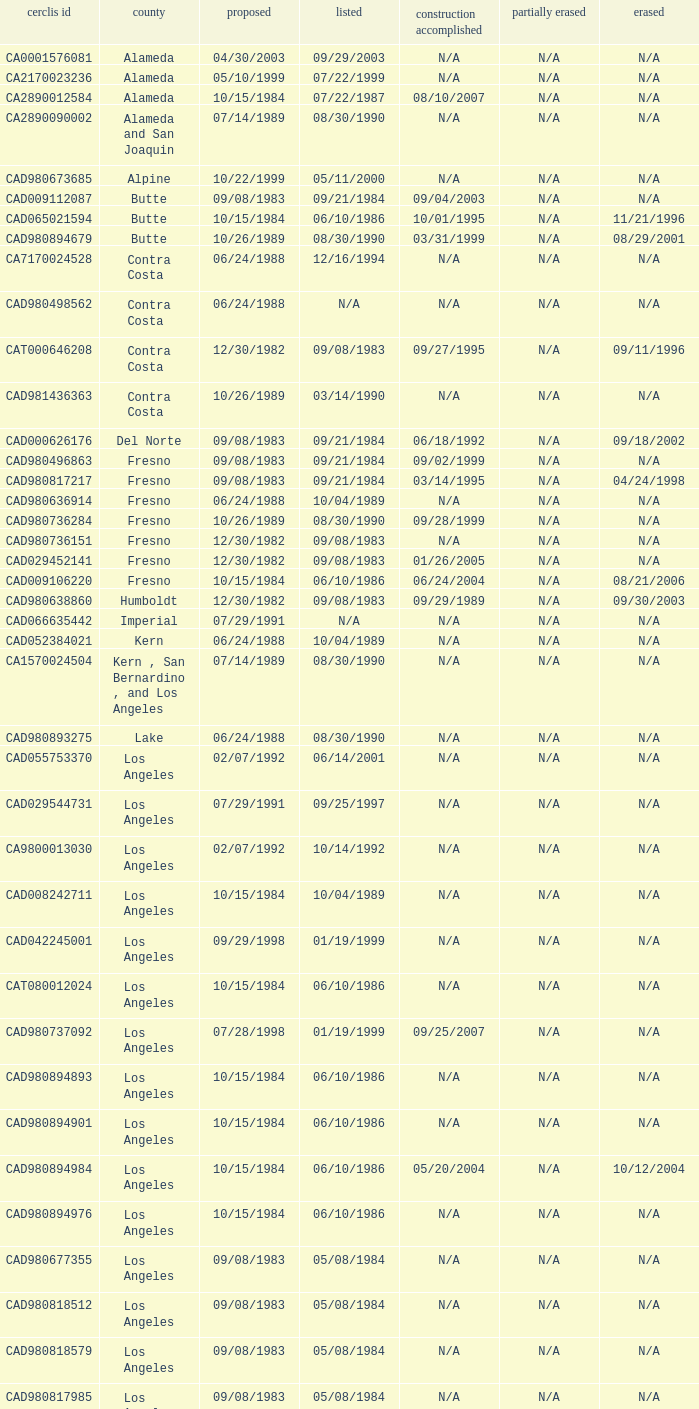What construction completed on 08/10/2007? 07/22/1987. 